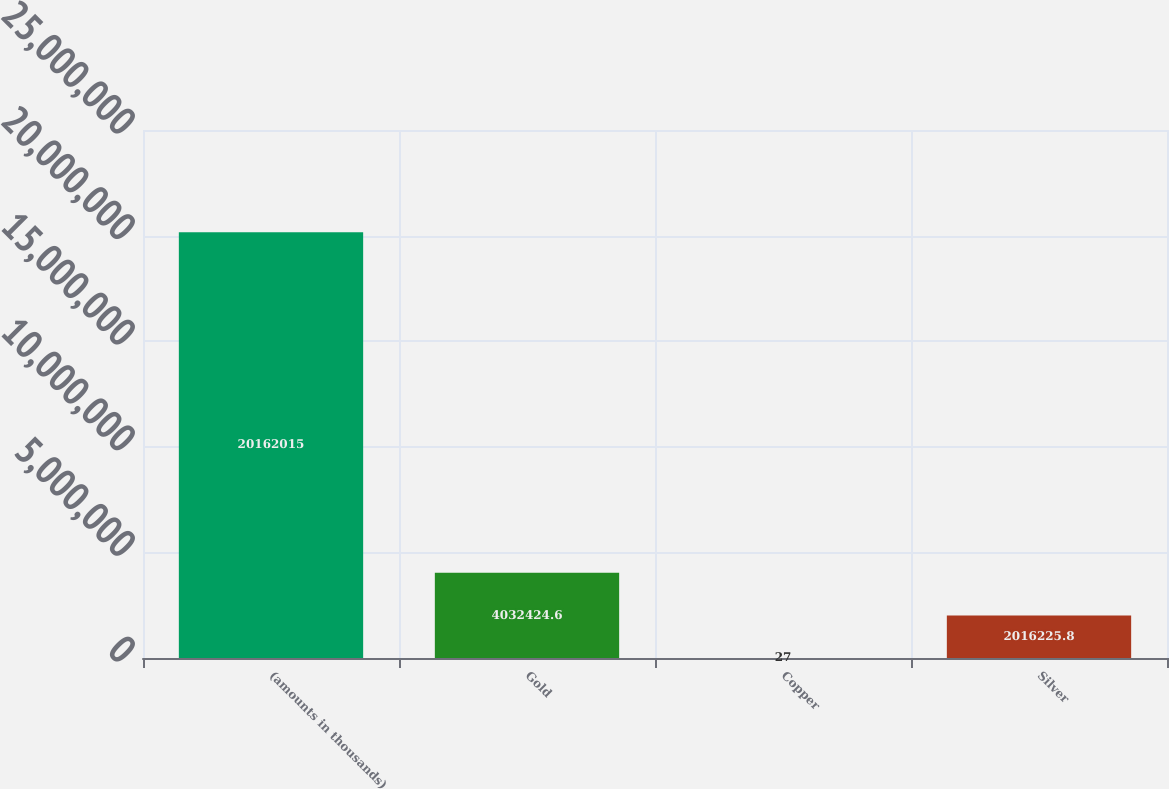Convert chart. <chart><loc_0><loc_0><loc_500><loc_500><bar_chart><fcel>(amounts in thousands)<fcel>Gold<fcel>Copper<fcel>Silver<nl><fcel>2.0162e+07<fcel>4.03242e+06<fcel>27<fcel>2.01623e+06<nl></chart> 